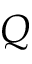Convert formula to latex. <formula><loc_0><loc_0><loc_500><loc_500>Q</formula> 